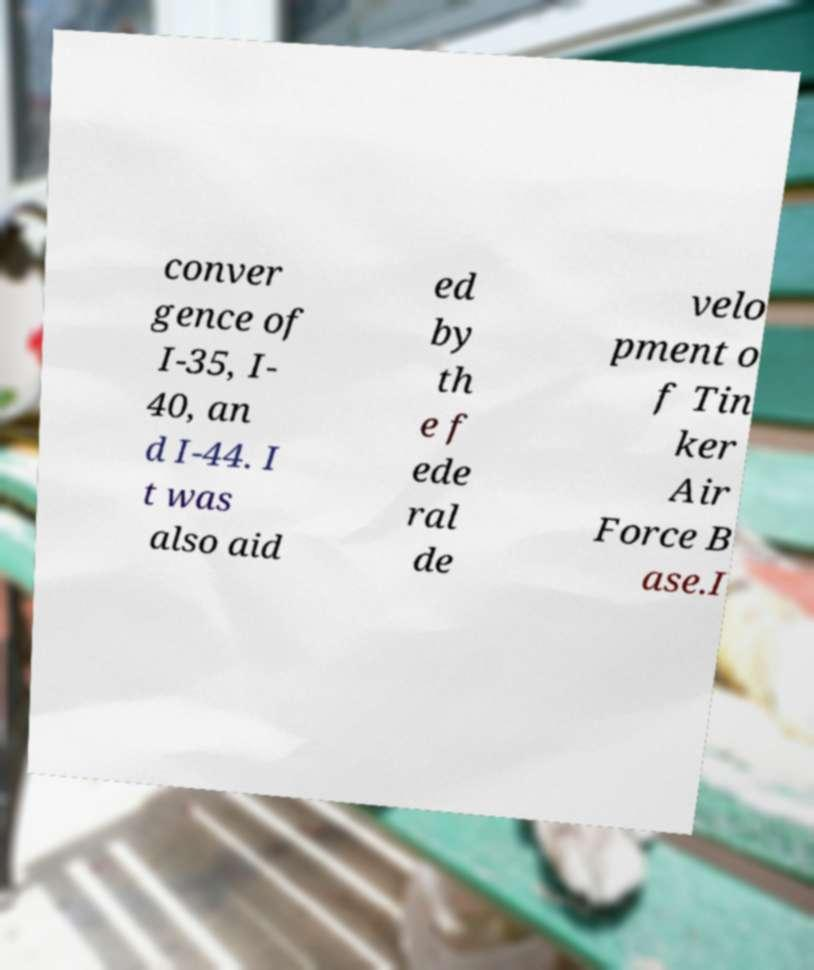Could you extract and type out the text from this image? conver gence of I-35, I- 40, an d I-44. I t was also aid ed by th e f ede ral de velo pment o f Tin ker Air Force B ase.I 